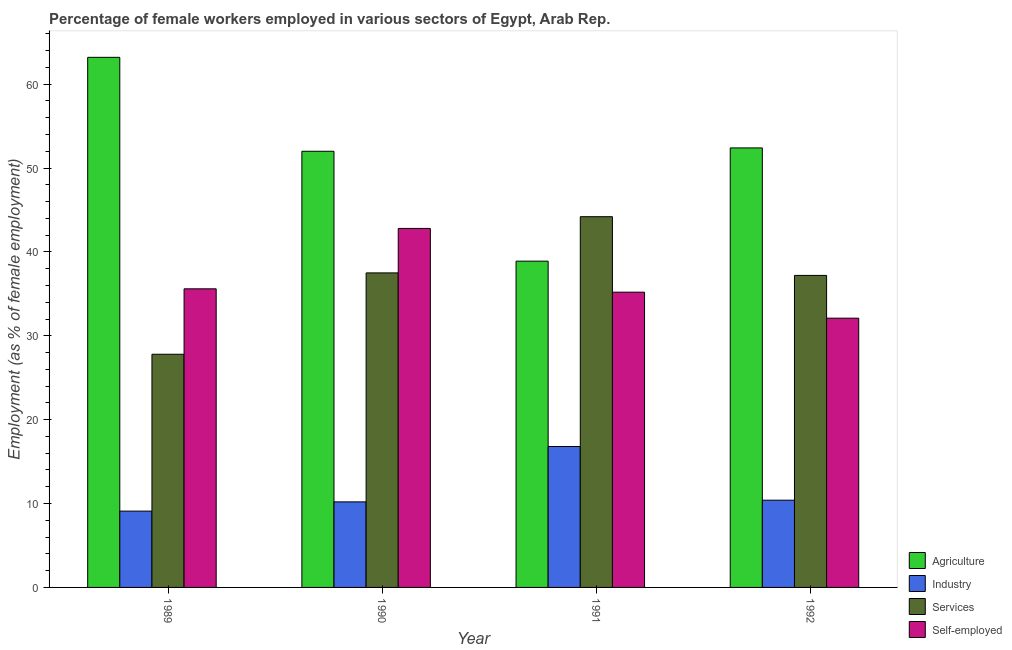How many groups of bars are there?
Offer a terse response. 4. Are the number of bars per tick equal to the number of legend labels?
Keep it short and to the point. Yes. Are the number of bars on each tick of the X-axis equal?
Your response must be concise. Yes. How many bars are there on the 2nd tick from the left?
Provide a short and direct response. 4. What is the label of the 1st group of bars from the left?
Your answer should be compact. 1989. What is the percentage of female workers in agriculture in 1989?
Keep it short and to the point. 63.2. Across all years, what is the maximum percentage of female workers in services?
Your answer should be very brief. 44.2. Across all years, what is the minimum percentage of female workers in agriculture?
Give a very brief answer. 38.9. In which year was the percentage of female workers in agriculture minimum?
Keep it short and to the point. 1991. What is the total percentage of self employed female workers in the graph?
Keep it short and to the point. 145.7. What is the difference between the percentage of female workers in industry in 1990 and that in 1992?
Your response must be concise. -0.2. What is the difference between the percentage of female workers in industry in 1989 and the percentage of female workers in agriculture in 1990?
Give a very brief answer. -1.1. What is the average percentage of female workers in industry per year?
Provide a succinct answer. 11.62. What is the ratio of the percentage of female workers in services in 1991 to that in 1992?
Your response must be concise. 1.19. Is the percentage of female workers in agriculture in 1989 less than that in 1991?
Provide a short and direct response. No. What is the difference between the highest and the second highest percentage of female workers in industry?
Your answer should be compact. 6.4. What is the difference between the highest and the lowest percentage of self employed female workers?
Your answer should be compact. 10.7. In how many years, is the percentage of self employed female workers greater than the average percentage of self employed female workers taken over all years?
Make the answer very short. 1. Is the sum of the percentage of female workers in industry in 1991 and 1992 greater than the maximum percentage of female workers in services across all years?
Provide a short and direct response. Yes. What does the 1st bar from the left in 1991 represents?
Offer a very short reply. Agriculture. What does the 3rd bar from the right in 1989 represents?
Ensure brevity in your answer.  Industry. How many bars are there?
Ensure brevity in your answer.  16. Are all the bars in the graph horizontal?
Provide a short and direct response. No. How many years are there in the graph?
Make the answer very short. 4. Does the graph contain any zero values?
Offer a very short reply. No. How many legend labels are there?
Your answer should be very brief. 4. What is the title of the graph?
Provide a short and direct response. Percentage of female workers employed in various sectors of Egypt, Arab Rep. What is the label or title of the X-axis?
Offer a terse response. Year. What is the label or title of the Y-axis?
Provide a short and direct response. Employment (as % of female employment). What is the Employment (as % of female employment) in Agriculture in 1989?
Offer a terse response. 63.2. What is the Employment (as % of female employment) in Industry in 1989?
Offer a very short reply. 9.1. What is the Employment (as % of female employment) of Services in 1989?
Offer a terse response. 27.8. What is the Employment (as % of female employment) of Self-employed in 1989?
Provide a succinct answer. 35.6. What is the Employment (as % of female employment) in Agriculture in 1990?
Your response must be concise. 52. What is the Employment (as % of female employment) in Industry in 1990?
Your answer should be compact. 10.2. What is the Employment (as % of female employment) in Services in 1990?
Your answer should be very brief. 37.5. What is the Employment (as % of female employment) in Self-employed in 1990?
Your answer should be compact. 42.8. What is the Employment (as % of female employment) of Agriculture in 1991?
Offer a terse response. 38.9. What is the Employment (as % of female employment) in Industry in 1991?
Your answer should be compact. 16.8. What is the Employment (as % of female employment) in Services in 1991?
Offer a terse response. 44.2. What is the Employment (as % of female employment) in Self-employed in 1991?
Provide a succinct answer. 35.2. What is the Employment (as % of female employment) of Agriculture in 1992?
Your answer should be very brief. 52.4. What is the Employment (as % of female employment) of Industry in 1992?
Give a very brief answer. 10.4. What is the Employment (as % of female employment) of Services in 1992?
Provide a short and direct response. 37.2. What is the Employment (as % of female employment) of Self-employed in 1992?
Give a very brief answer. 32.1. Across all years, what is the maximum Employment (as % of female employment) of Agriculture?
Provide a succinct answer. 63.2. Across all years, what is the maximum Employment (as % of female employment) of Industry?
Make the answer very short. 16.8. Across all years, what is the maximum Employment (as % of female employment) in Services?
Offer a terse response. 44.2. Across all years, what is the maximum Employment (as % of female employment) in Self-employed?
Your answer should be very brief. 42.8. Across all years, what is the minimum Employment (as % of female employment) in Agriculture?
Your answer should be compact. 38.9. Across all years, what is the minimum Employment (as % of female employment) of Industry?
Provide a short and direct response. 9.1. Across all years, what is the minimum Employment (as % of female employment) of Services?
Ensure brevity in your answer.  27.8. Across all years, what is the minimum Employment (as % of female employment) in Self-employed?
Your answer should be very brief. 32.1. What is the total Employment (as % of female employment) in Agriculture in the graph?
Ensure brevity in your answer.  206.5. What is the total Employment (as % of female employment) in Industry in the graph?
Make the answer very short. 46.5. What is the total Employment (as % of female employment) in Services in the graph?
Offer a very short reply. 146.7. What is the total Employment (as % of female employment) of Self-employed in the graph?
Your answer should be compact. 145.7. What is the difference between the Employment (as % of female employment) of Industry in 1989 and that in 1990?
Provide a succinct answer. -1.1. What is the difference between the Employment (as % of female employment) in Services in 1989 and that in 1990?
Ensure brevity in your answer.  -9.7. What is the difference between the Employment (as % of female employment) of Agriculture in 1989 and that in 1991?
Keep it short and to the point. 24.3. What is the difference between the Employment (as % of female employment) in Services in 1989 and that in 1991?
Provide a short and direct response. -16.4. What is the difference between the Employment (as % of female employment) in Self-employed in 1989 and that in 1991?
Provide a short and direct response. 0.4. What is the difference between the Employment (as % of female employment) of Industry in 1989 and that in 1992?
Your answer should be compact. -1.3. What is the difference between the Employment (as % of female employment) in Self-employed in 1989 and that in 1992?
Give a very brief answer. 3.5. What is the difference between the Employment (as % of female employment) of Services in 1990 and that in 1991?
Offer a very short reply. -6.7. What is the difference between the Employment (as % of female employment) of Agriculture in 1990 and that in 1992?
Offer a terse response. -0.4. What is the difference between the Employment (as % of female employment) of Industry in 1990 and that in 1992?
Your answer should be compact. -0.2. What is the difference between the Employment (as % of female employment) of Services in 1990 and that in 1992?
Offer a terse response. 0.3. What is the difference between the Employment (as % of female employment) of Industry in 1991 and that in 1992?
Give a very brief answer. 6.4. What is the difference between the Employment (as % of female employment) in Services in 1991 and that in 1992?
Ensure brevity in your answer.  7. What is the difference between the Employment (as % of female employment) in Self-employed in 1991 and that in 1992?
Your answer should be compact. 3.1. What is the difference between the Employment (as % of female employment) in Agriculture in 1989 and the Employment (as % of female employment) in Services in 1990?
Provide a succinct answer. 25.7. What is the difference between the Employment (as % of female employment) in Agriculture in 1989 and the Employment (as % of female employment) in Self-employed in 1990?
Your answer should be very brief. 20.4. What is the difference between the Employment (as % of female employment) in Industry in 1989 and the Employment (as % of female employment) in Services in 1990?
Offer a terse response. -28.4. What is the difference between the Employment (as % of female employment) of Industry in 1989 and the Employment (as % of female employment) of Self-employed in 1990?
Provide a short and direct response. -33.7. What is the difference between the Employment (as % of female employment) in Services in 1989 and the Employment (as % of female employment) in Self-employed in 1990?
Ensure brevity in your answer.  -15. What is the difference between the Employment (as % of female employment) of Agriculture in 1989 and the Employment (as % of female employment) of Industry in 1991?
Keep it short and to the point. 46.4. What is the difference between the Employment (as % of female employment) in Agriculture in 1989 and the Employment (as % of female employment) in Services in 1991?
Your response must be concise. 19. What is the difference between the Employment (as % of female employment) in Agriculture in 1989 and the Employment (as % of female employment) in Self-employed in 1991?
Offer a terse response. 28. What is the difference between the Employment (as % of female employment) of Industry in 1989 and the Employment (as % of female employment) of Services in 1991?
Ensure brevity in your answer.  -35.1. What is the difference between the Employment (as % of female employment) of Industry in 1989 and the Employment (as % of female employment) of Self-employed in 1991?
Give a very brief answer. -26.1. What is the difference between the Employment (as % of female employment) of Services in 1989 and the Employment (as % of female employment) of Self-employed in 1991?
Offer a very short reply. -7.4. What is the difference between the Employment (as % of female employment) of Agriculture in 1989 and the Employment (as % of female employment) of Industry in 1992?
Make the answer very short. 52.8. What is the difference between the Employment (as % of female employment) of Agriculture in 1989 and the Employment (as % of female employment) of Services in 1992?
Provide a succinct answer. 26. What is the difference between the Employment (as % of female employment) of Agriculture in 1989 and the Employment (as % of female employment) of Self-employed in 1992?
Make the answer very short. 31.1. What is the difference between the Employment (as % of female employment) in Industry in 1989 and the Employment (as % of female employment) in Services in 1992?
Offer a terse response. -28.1. What is the difference between the Employment (as % of female employment) in Services in 1989 and the Employment (as % of female employment) in Self-employed in 1992?
Provide a succinct answer. -4.3. What is the difference between the Employment (as % of female employment) in Agriculture in 1990 and the Employment (as % of female employment) in Industry in 1991?
Provide a short and direct response. 35.2. What is the difference between the Employment (as % of female employment) in Agriculture in 1990 and the Employment (as % of female employment) in Services in 1991?
Provide a short and direct response. 7.8. What is the difference between the Employment (as % of female employment) in Agriculture in 1990 and the Employment (as % of female employment) in Self-employed in 1991?
Your response must be concise. 16.8. What is the difference between the Employment (as % of female employment) of Industry in 1990 and the Employment (as % of female employment) of Services in 1991?
Your answer should be very brief. -34. What is the difference between the Employment (as % of female employment) in Services in 1990 and the Employment (as % of female employment) in Self-employed in 1991?
Your response must be concise. 2.3. What is the difference between the Employment (as % of female employment) in Agriculture in 1990 and the Employment (as % of female employment) in Industry in 1992?
Provide a succinct answer. 41.6. What is the difference between the Employment (as % of female employment) in Agriculture in 1990 and the Employment (as % of female employment) in Services in 1992?
Offer a terse response. 14.8. What is the difference between the Employment (as % of female employment) of Agriculture in 1990 and the Employment (as % of female employment) of Self-employed in 1992?
Give a very brief answer. 19.9. What is the difference between the Employment (as % of female employment) in Industry in 1990 and the Employment (as % of female employment) in Self-employed in 1992?
Ensure brevity in your answer.  -21.9. What is the difference between the Employment (as % of female employment) of Services in 1990 and the Employment (as % of female employment) of Self-employed in 1992?
Offer a very short reply. 5.4. What is the difference between the Employment (as % of female employment) of Industry in 1991 and the Employment (as % of female employment) of Services in 1992?
Offer a terse response. -20.4. What is the difference between the Employment (as % of female employment) of Industry in 1991 and the Employment (as % of female employment) of Self-employed in 1992?
Make the answer very short. -15.3. What is the average Employment (as % of female employment) of Agriculture per year?
Provide a succinct answer. 51.62. What is the average Employment (as % of female employment) in Industry per year?
Your answer should be compact. 11.62. What is the average Employment (as % of female employment) of Services per year?
Give a very brief answer. 36.67. What is the average Employment (as % of female employment) in Self-employed per year?
Keep it short and to the point. 36.42. In the year 1989, what is the difference between the Employment (as % of female employment) in Agriculture and Employment (as % of female employment) in Industry?
Provide a short and direct response. 54.1. In the year 1989, what is the difference between the Employment (as % of female employment) in Agriculture and Employment (as % of female employment) in Services?
Give a very brief answer. 35.4. In the year 1989, what is the difference between the Employment (as % of female employment) in Agriculture and Employment (as % of female employment) in Self-employed?
Make the answer very short. 27.6. In the year 1989, what is the difference between the Employment (as % of female employment) in Industry and Employment (as % of female employment) in Services?
Ensure brevity in your answer.  -18.7. In the year 1989, what is the difference between the Employment (as % of female employment) in Industry and Employment (as % of female employment) in Self-employed?
Your response must be concise. -26.5. In the year 1990, what is the difference between the Employment (as % of female employment) in Agriculture and Employment (as % of female employment) in Industry?
Your answer should be compact. 41.8. In the year 1990, what is the difference between the Employment (as % of female employment) in Industry and Employment (as % of female employment) in Services?
Keep it short and to the point. -27.3. In the year 1990, what is the difference between the Employment (as % of female employment) of Industry and Employment (as % of female employment) of Self-employed?
Your answer should be compact. -32.6. In the year 1990, what is the difference between the Employment (as % of female employment) of Services and Employment (as % of female employment) of Self-employed?
Ensure brevity in your answer.  -5.3. In the year 1991, what is the difference between the Employment (as % of female employment) in Agriculture and Employment (as % of female employment) in Industry?
Your response must be concise. 22.1. In the year 1991, what is the difference between the Employment (as % of female employment) of Industry and Employment (as % of female employment) of Services?
Give a very brief answer. -27.4. In the year 1991, what is the difference between the Employment (as % of female employment) in Industry and Employment (as % of female employment) in Self-employed?
Your answer should be compact. -18.4. In the year 1992, what is the difference between the Employment (as % of female employment) of Agriculture and Employment (as % of female employment) of Industry?
Ensure brevity in your answer.  42. In the year 1992, what is the difference between the Employment (as % of female employment) in Agriculture and Employment (as % of female employment) in Self-employed?
Offer a terse response. 20.3. In the year 1992, what is the difference between the Employment (as % of female employment) in Industry and Employment (as % of female employment) in Services?
Keep it short and to the point. -26.8. In the year 1992, what is the difference between the Employment (as % of female employment) of Industry and Employment (as % of female employment) of Self-employed?
Keep it short and to the point. -21.7. In the year 1992, what is the difference between the Employment (as % of female employment) of Services and Employment (as % of female employment) of Self-employed?
Your response must be concise. 5.1. What is the ratio of the Employment (as % of female employment) in Agriculture in 1989 to that in 1990?
Make the answer very short. 1.22. What is the ratio of the Employment (as % of female employment) of Industry in 1989 to that in 1990?
Offer a terse response. 0.89. What is the ratio of the Employment (as % of female employment) of Services in 1989 to that in 1990?
Ensure brevity in your answer.  0.74. What is the ratio of the Employment (as % of female employment) in Self-employed in 1989 to that in 1990?
Give a very brief answer. 0.83. What is the ratio of the Employment (as % of female employment) of Agriculture in 1989 to that in 1991?
Provide a short and direct response. 1.62. What is the ratio of the Employment (as % of female employment) in Industry in 1989 to that in 1991?
Provide a short and direct response. 0.54. What is the ratio of the Employment (as % of female employment) of Services in 1989 to that in 1991?
Provide a succinct answer. 0.63. What is the ratio of the Employment (as % of female employment) in Self-employed in 1989 to that in 1991?
Ensure brevity in your answer.  1.01. What is the ratio of the Employment (as % of female employment) of Agriculture in 1989 to that in 1992?
Your answer should be very brief. 1.21. What is the ratio of the Employment (as % of female employment) in Services in 1989 to that in 1992?
Your response must be concise. 0.75. What is the ratio of the Employment (as % of female employment) in Self-employed in 1989 to that in 1992?
Provide a succinct answer. 1.11. What is the ratio of the Employment (as % of female employment) in Agriculture in 1990 to that in 1991?
Offer a very short reply. 1.34. What is the ratio of the Employment (as % of female employment) of Industry in 1990 to that in 1991?
Keep it short and to the point. 0.61. What is the ratio of the Employment (as % of female employment) in Services in 1990 to that in 1991?
Offer a very short reply. 0.85. What is the ratio of the Employment (as % of female employment) in Self-employed in 1990 to that in 1991?
Provide a short and direct response. 1.22. What is the ratio of the Employment (as % of female employment) in Industry in 1990 to that in 1992?
Offer a terse response. 0.98. What is the ratio of the Employment (as % of female employment) in Self-employed in 1990 to that in 1992?
Your answer should be very brief. 1.33. What is the ratio of the Employment (as % of female employment) of Agriculture in 1991 to that in 1992?
Give a very brief answer. 0.74. What is the ratio of the Employment (as % of female employment) of Industry in 1991 to that in 1992?
Your response must be concise. 1.62. What is the ratio of the Employment (as % of female employment) in Services in 1991 to that in 1992?
Your response must be concise. 1.19. What is the ratio of the Employment (as % of female employment) in Self-employed in 1991 to that in 1992?
Offer a very short reply. 1.1. What is the difference between the highest and the second highest Employment (as % of female employment) of Industry?
Give a very brief answer. 6.4. What is the difference between the highest and the lowest Employment (as % of female employment) of Agriculture?
Provide a succinct answer. 24.3. What is the difference between the highest and the lowest Employment (as % of female employment) in Industry?
Offer a terse response. 7.7. What is the difference between the highest and the lowest Employment (as % of female employment) in Services?
Offer a terse response. 16.4. What is the difference between the highest and the lowest Employment (as % of female employment) of Self-employed?
Your answer should be compact. 10.7. 